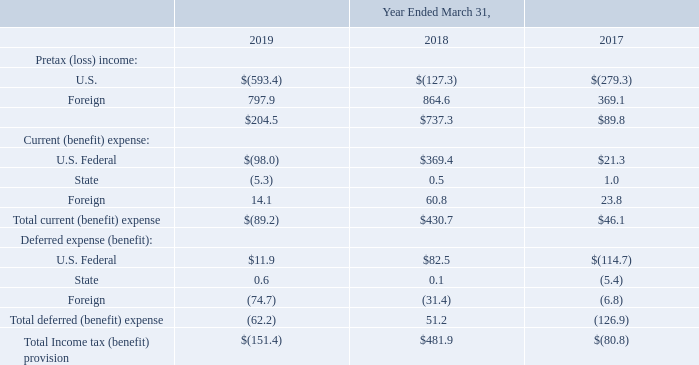Note 11. Income Taxes
The income tax provision consists of the following (amounts in millions):
On December 22, 2017, the Tax Cuts and Jobs Act (the "Act") was enacted into law. The Act provides for numerous significant tax law changes and modifications including the reduction of the U.S. federal corporate income tax rate from 35.0% to 21.0%, the requirement for companies to pay a one-time transition tax on earnings of certain foreign subsidiaries that were previously tax deferred and the creation of new taxes on certain foreign-sourced earnings.
Accounting Standards Codification ("ASC") 740, Income Taxes, requires companies to recognize the effect of the tax law changes in the period of enactment. However, the SEC staff issued Staff Accounting Bulletin ("SAB") 118, which allowed companies to record provisional amounts during a measurement period that is similar to the measurement period used when accounting for business combinations. The Company recorded a reasonable estimate when measurable and with the understanding that the provisional amount was subject to further adjustments under SAB 118. In addition, for significant items for which the Company could not make a reasonable estimate, no provisional amounts were recorded. As of December 31, 2018, the Company completed its review of the previously recorded provisional amounts related to the Act, recorded necessary adjustments, and the amounts are now final under SAB 118.
As of March 31, 2018, the Company remeasured certain deferred tax assets and liabilities based on the rates at which they were expected to reverse in the future (which was generally 21%), by recording a provisional income tax benefit of $136.7 million. Upon further analysis of certain aspects of the Act and refinement of its calculations during the period ended December 31, 2018, the Company did not make adjustments to the provisional amount
The one-time transition tax is based on the Company's total post-1986 earnings and profits (E&P), the tax on which the Company previously deferred from U.S. income taxes under U.S. law. The Company recorded a provisional amount for its one-time transition tax expense for each of its foreign subsidiaries, resulting in a transition tax expense of $644.7 million at March 31, 2018. Upon further analyses of the Act and notices and regulations issued and proposed by the U.S. Department of the Treasury and the Internal Revenue Service, the Company finalized its calculations of the transition tax expense during the period ended December 31, 2018. The Company increased its March 31, 2018 provisional amount by $13.1 million to $657.8 million, which is included as a component of income tax expense from continuing operations. The measurement period adjustment of $13.1 million decreased basic and diluted net income per common share by $0.06 and $0.05, respectively, for the year ended March 31, 2019.
The Company intends to invest substantially all of its foreign subsidiary earnings, as well as its capital in its foreign subsidiaries, indefinitely outside of the U.S. in those jurisdictions in which the Company would incur significant, additional costs upon repatriation of such amounts. It is not practical to estimate the additional tax that would be incurred, if any, if the permanently reinvested earnings were repatriated.
Which legislation was enacted into law on December 22, 2017? The tax cuts and jobs act. What was the pretax (loss) income for the U.S. in 2019?
Answer scale should be: million. (593.4). Which years does the table provide information for the company's income tax provision? 2019, 2018, 2017. What was the change in the Deferred expense for State between 2018 and 2019?
Answer scale should be: million. 0.6-0.1
Answer: 0.5. What was the change in the Foreign Pretax income between 2018 and 2019? 
Answer scale should be: million. 797.9-864.6
Answer: -66.7. What was the percentage change in the Total current expense between 2017 and 2018?
Answer scale should be: percent. (430.7-46.1)/46.1
Answer: 834.27. 